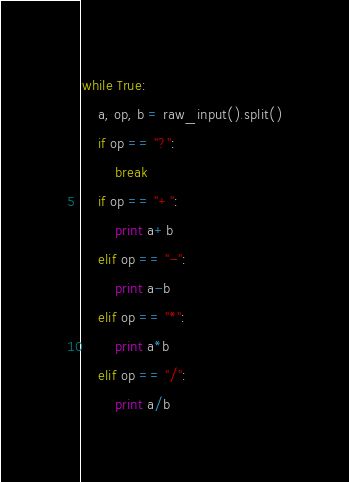<code> <loc_0><loc_0><loc_500><loc_500><_Python_>while True:
    a, op, b = raw_input().split()
    if op == "?":
        break
    if op == "+":
        print a+b
    elif op == "-":
        print a-b
    elif op == "*":
        print a*b
    elif op == "/":
        print a/b</code> 